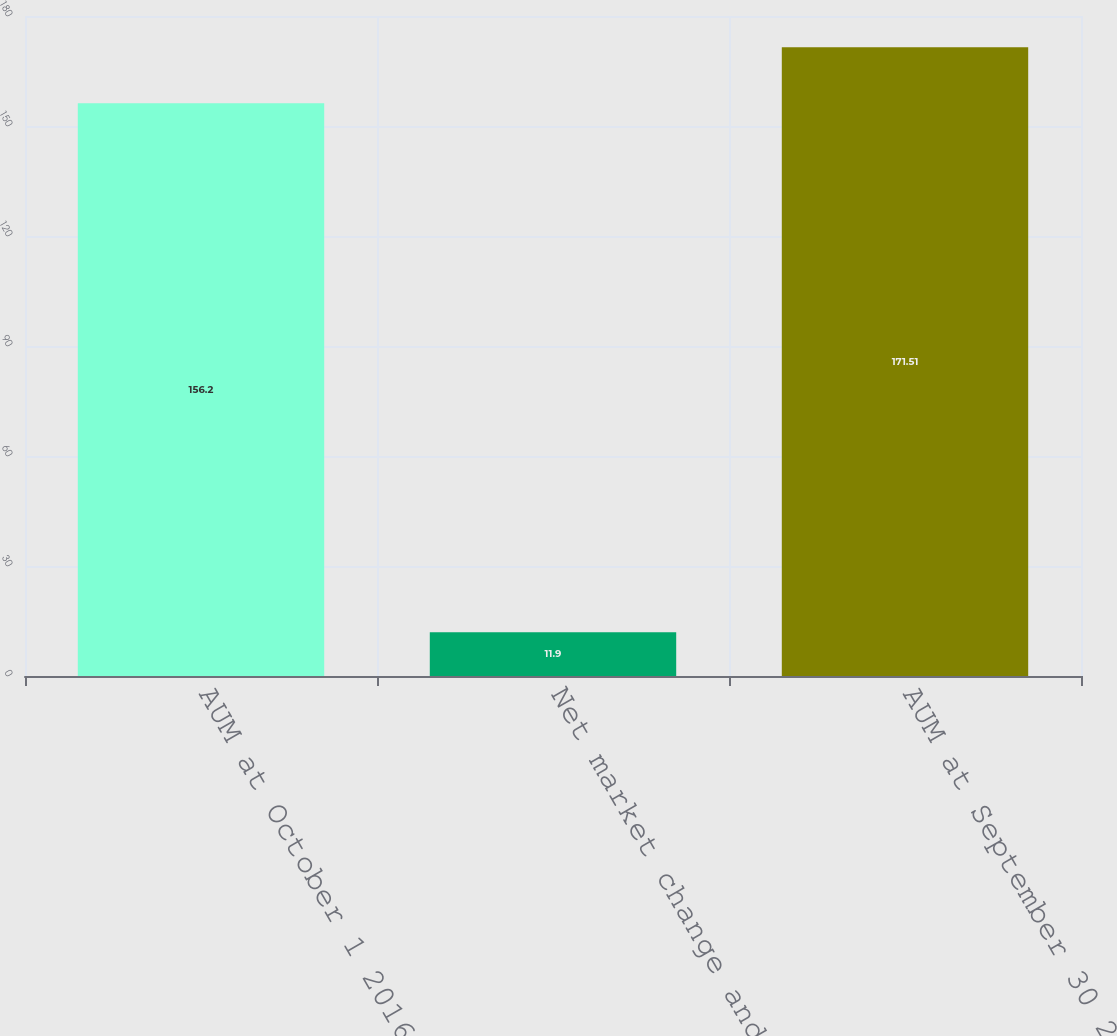Convert chart. <chart><loc_0><loc_0><loc_500><loc_500><bar_chart><fcel>AUM at October 1 2016<fcel>Net market change and other<fcel>AUM at September 30 2017<nl><fcel>156.2<fcel>11.9<fcel>171.51<nl></chart> 